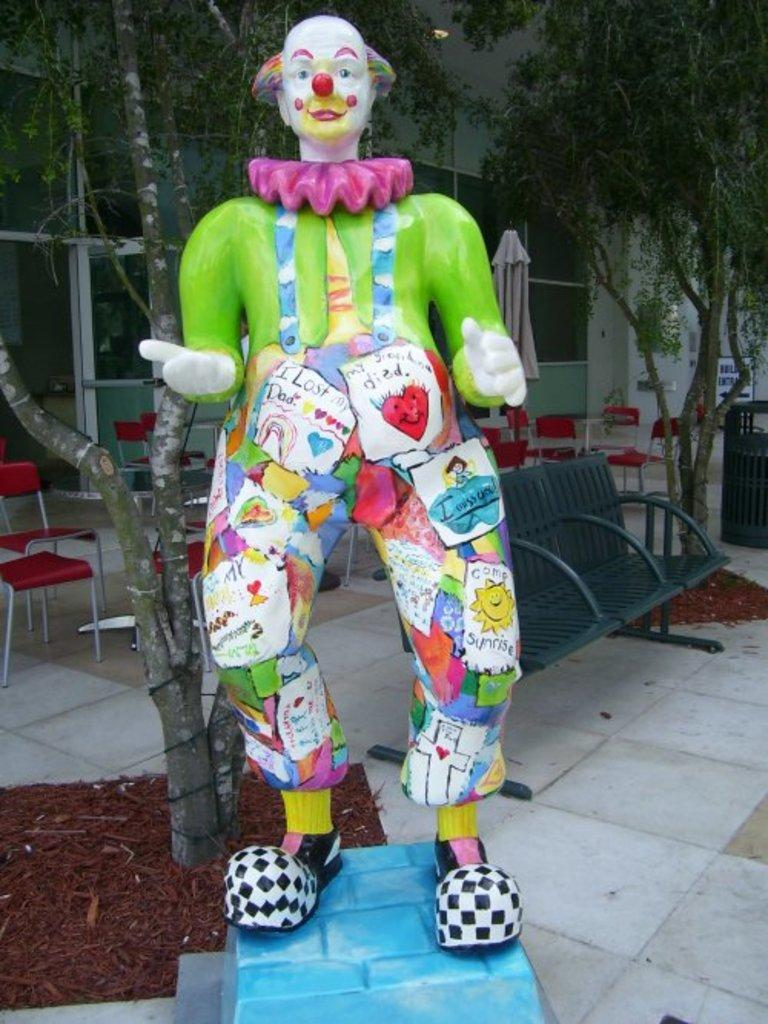What is the main subject of the image? There is a sculpture in the image. What can be seen in the background of the image? There are trees behind the sculpture. What type of furniture is present in the image? There are chairs in the image. What type of structure is visible in the image? There is a building in the image. How many girls are sitting on the chairs in the image? There is no mention of girls or chairs with people sitting on them in the image. 